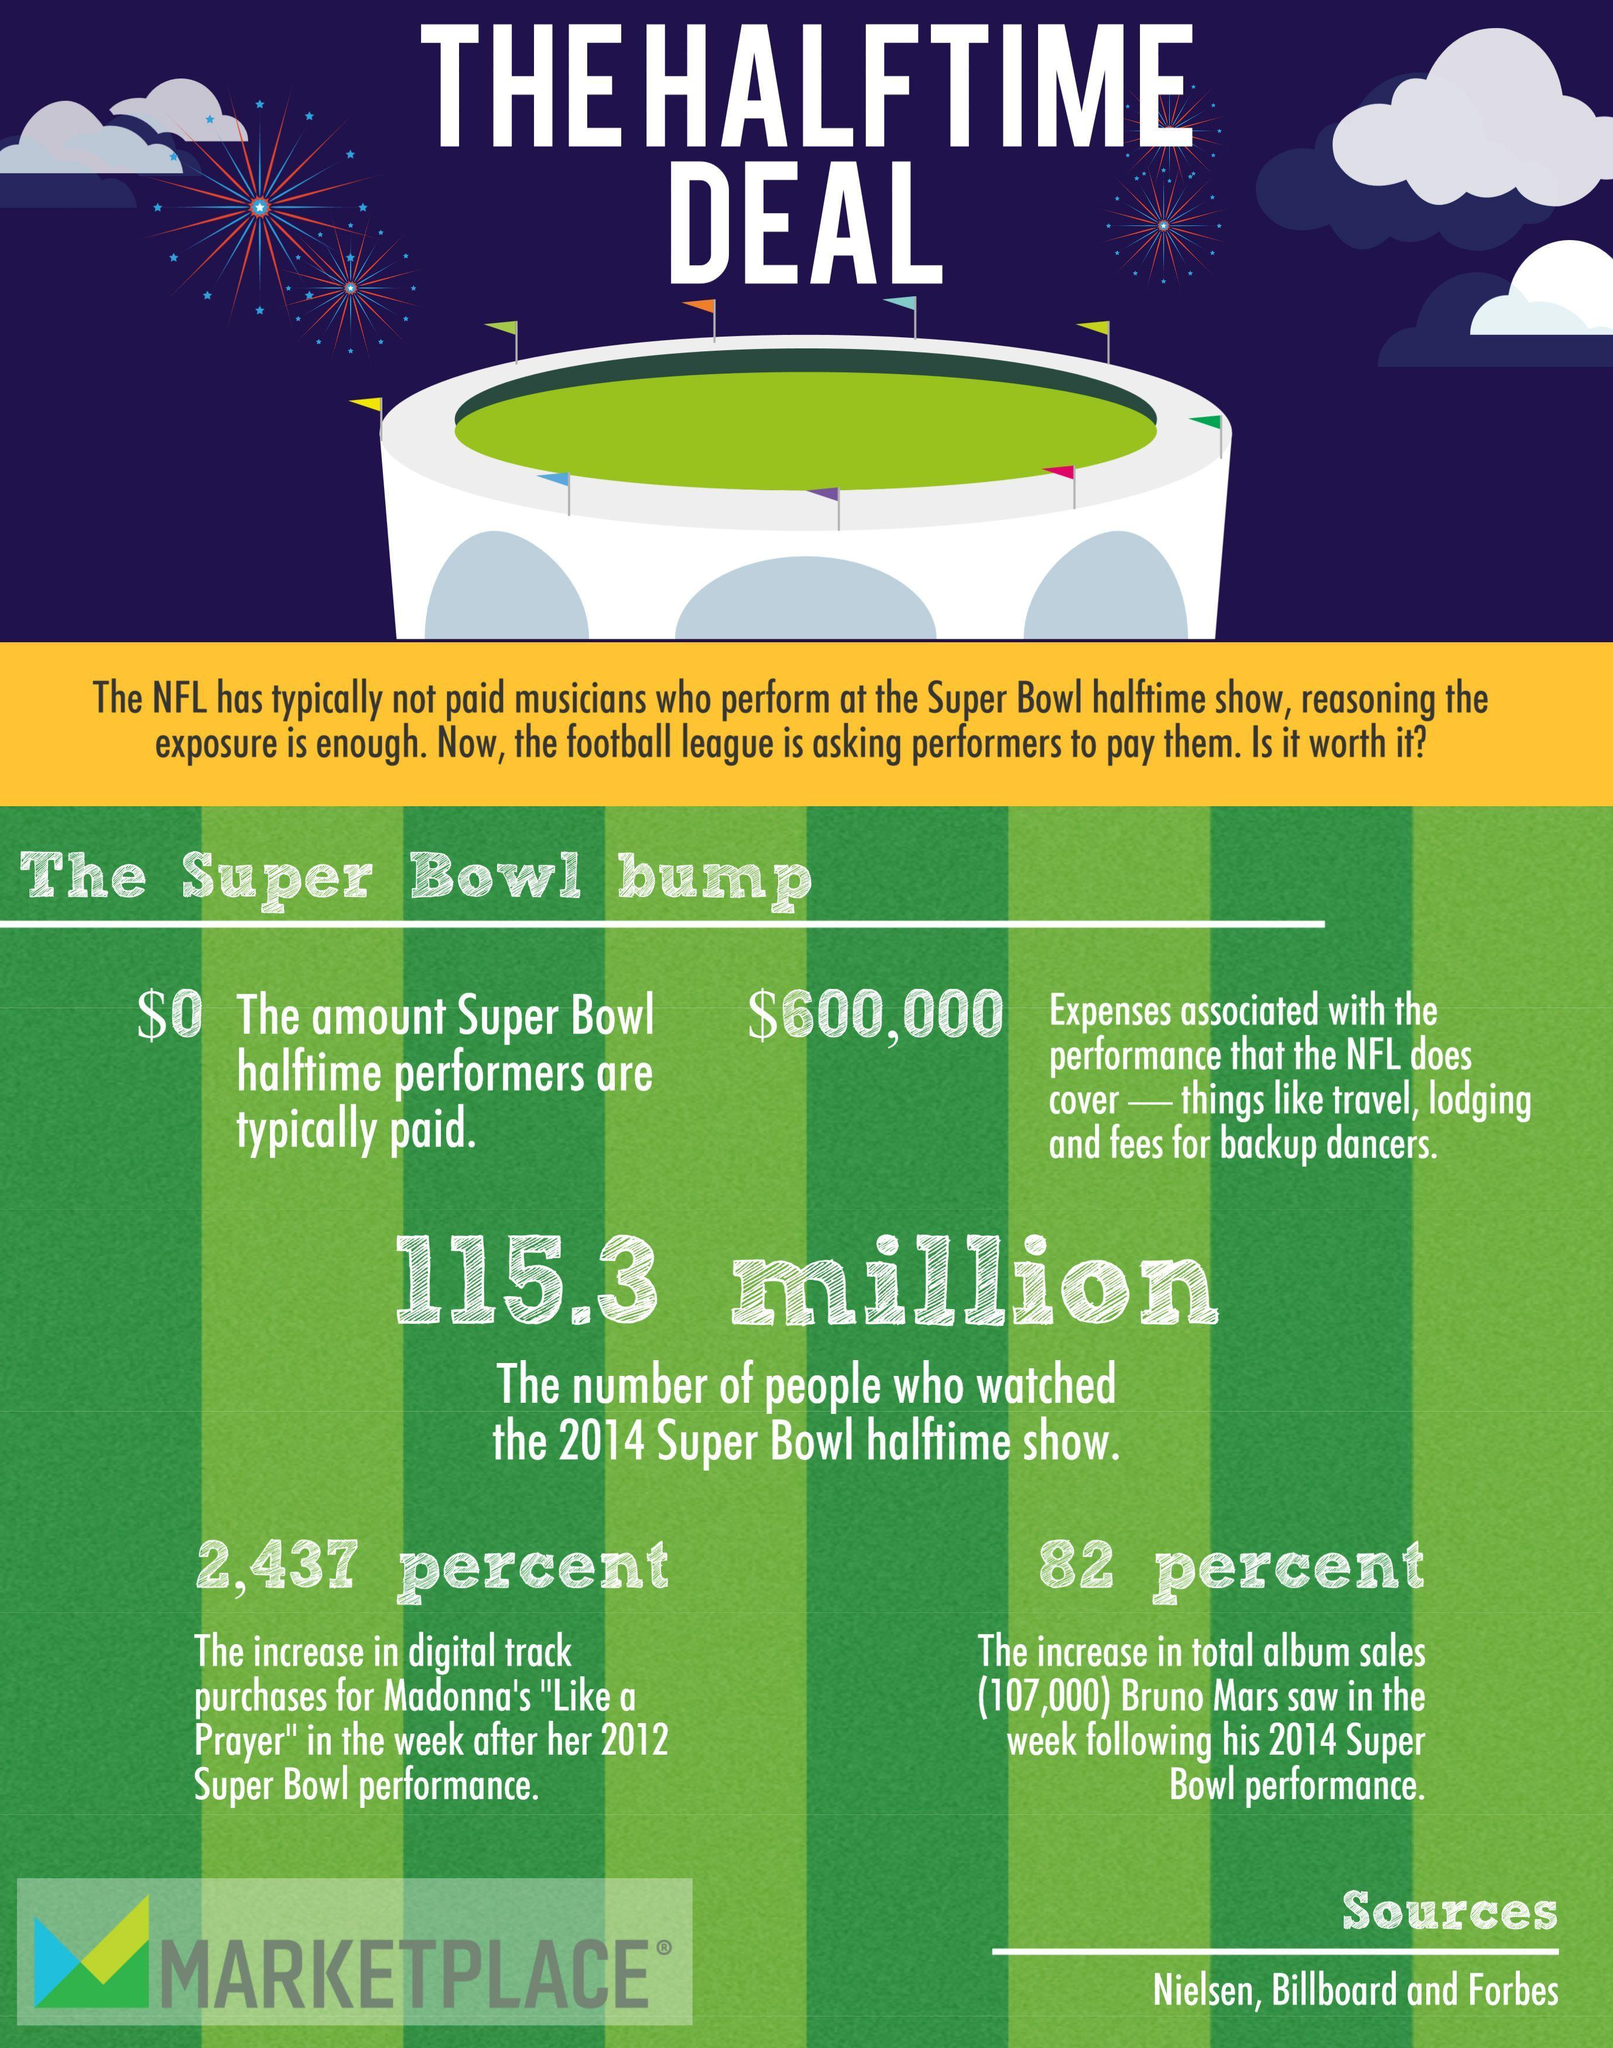What is the percent increase in the total album sales of Bruno Mars in the week following his 2014 Super Bowl performance?
Answer the question with a short phrase. 82 What is the number of people who watched the 2014 Super Bowl halftime show? 115.3 million What is the amount paid to Super Bowl half time performers? $0 